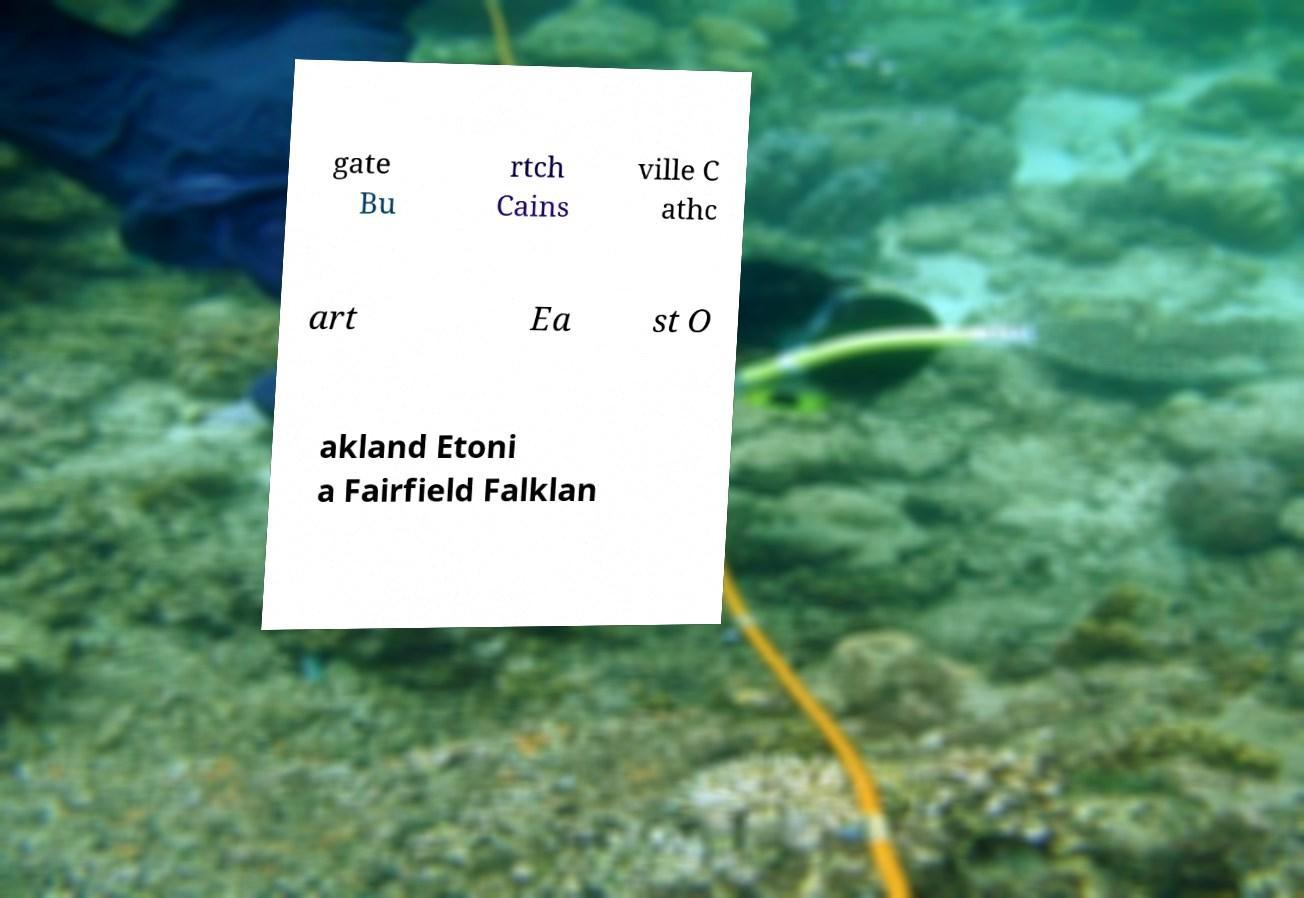I need the written content from this picture converted into text. Can you do that? gate Bu rtch Cains ville C athc art Ea st O akland Etoni a Fairfield Falklan 